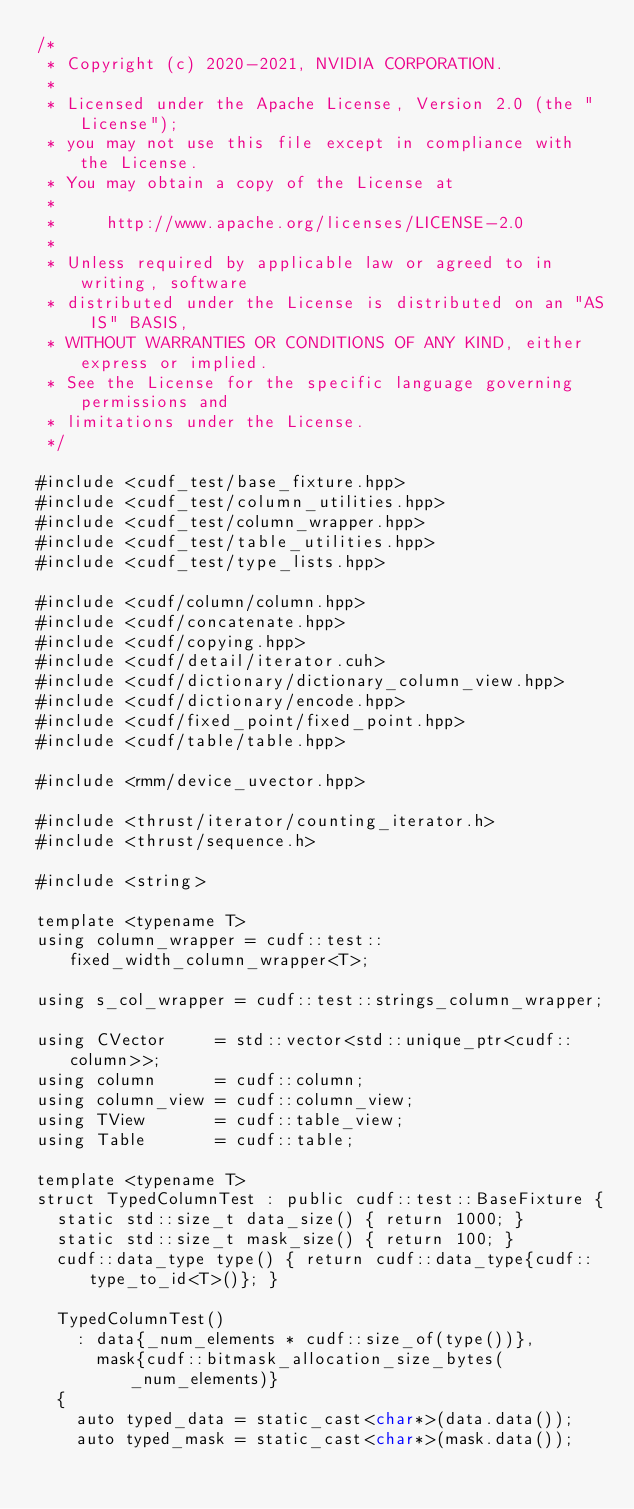Convert code to text. <code><loc_0><loc_0><loc_500><loc_500><_Cuda_>/*
 * Copyright (c) 2020-2021, NVIDIA CORPORATION.
 *
 * Licensed under the Apache License, Version 2.0 (the "License");
 * you may not use this file except in compliance with the License.
 * You may obtain a copy of the License at
 *
 *     http://www.apache.org/licenses/LICENSE-2.0
 *
 * Unless required by applicable law or agreed to in writing, software
 * distributed under the License is distributed on an "AS IS" BASIS,
 * WITHOUT WARRANTIES OR CONDITIONS OF ANY KIND, either express or implied.
 * See the License for the specific language governing permissions and
 * limitations under the License.
 */

#include <cudf_test/base_fixture.hpp>
#include <cudf_test/column_utilities.hpp>
#include <cudf_test/column_wrapper.hpp>
#include <cudf_test/table_utilities.hpp>
#include <cudf_test/type_lists.hpp>

#include <cudf/column/column.hpp>
#include <cudf/concatenate.hpp>
#include <cudf/copying.hpp>
#include <cudf/detail/iterator.cuh>
#include <cudf/dictionary/dictionary_column_view.hpp>
#include <cudf/dictionary/encode.hpp>
#include <cudf/fixed_point/fixed_point.hpp>
#include <cudf/table/table.hpp>

#include <rmm/device_uvector.hpp>

#include <thrust/iterator/counting_iterator.h>
#include <thrust/sequence.h>

#include <string>

template <typename T>
using column_wrapper = cudf::test::fixed_width_column_wrapper<T>;

using s_col_wrapper = cudf::test::strings_column_wrapper;

using CVector     = std::vector<std::unique_ptr<cudf::column>>;
using column      = cudf::column;
using column_view = cudf::column_view;
using TView       = cudf::table_view;
using Table       = cudf::table;

template <typename T>
struct TypedColumnTest : public cudf::test::BaseFixture {
  static std::size_t data_size() { return 1000; }
  static std::size_t mask_size() { return 100; }
  cudf::data_type type() { return cudf::data_type{cudf::type_to_id<T>()}; }

  TypedColumnTest()
    : data{_num_elements * cudf::size_of(type())},
      mask{cudf::bitmask_allocation_size_bytes(_num_elements)}
  {
    auto typed_data = static_cast<char*>(data.data());
    auto typed_mask = static_cast<char*>(mask.data());</code> 